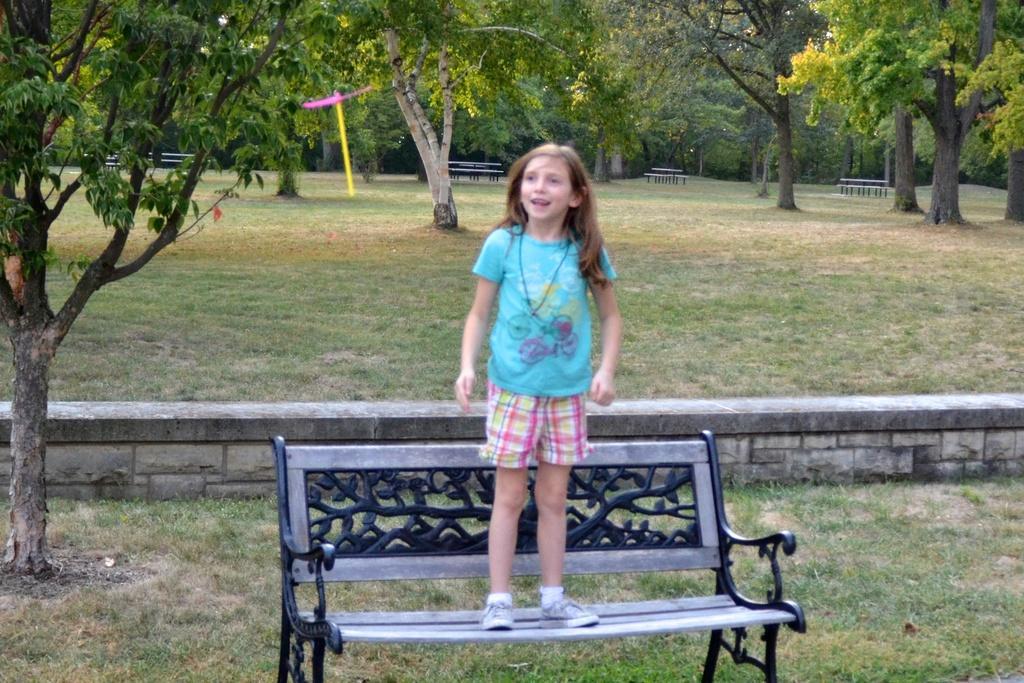How would you summarize this image in a sentence or two? In this image I can see a girl standing on the bench at the background we can see trees. 